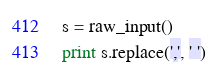<code> <loc_0><loc_0><loc_500><loc_500><_Python_>s = raw_input()
print s.replace(',', ' ')</code> 